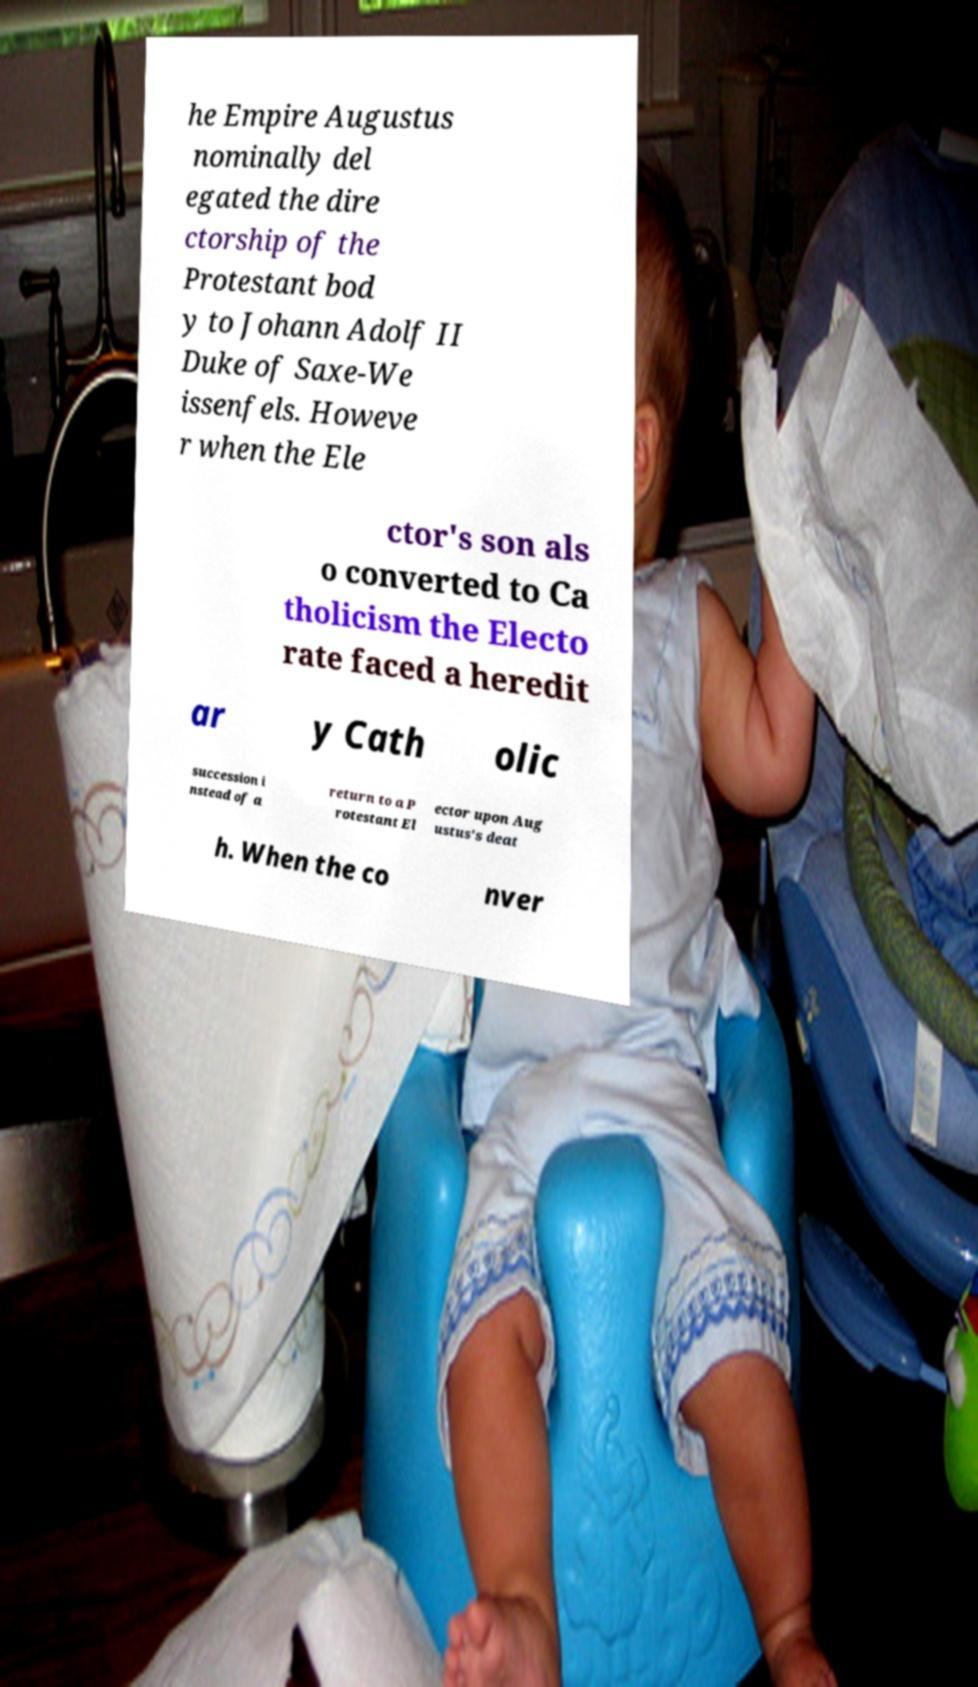Can you accurately transcribe the text from the provided image for me? he Empire Augustus nominally del egated the dire ctorship of the Protestant bod y to Johann Adolf II Duke of Saxe-We issenfels. Howeve r when the Ele ctor's son als o converted to Ca tholicism the Electo rate faced a heredit ar y Cath olic succession i nstead of a return to a P rotestant El ector upon Aug ustus's deat h. When the co nver 